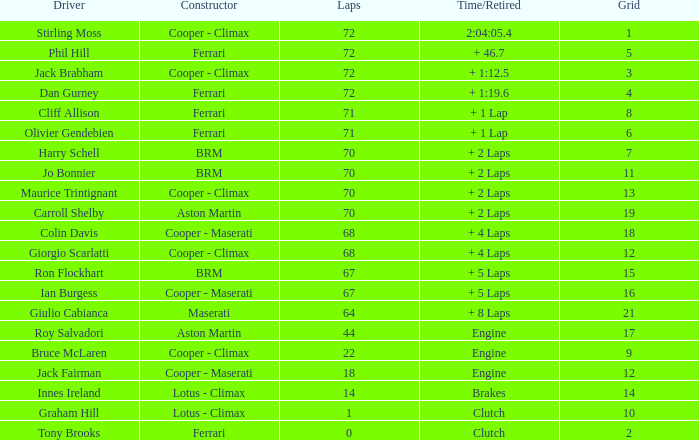What is the time/retired for phil hill with over 67 laps and a grad smaller than 18? + 46.7. 